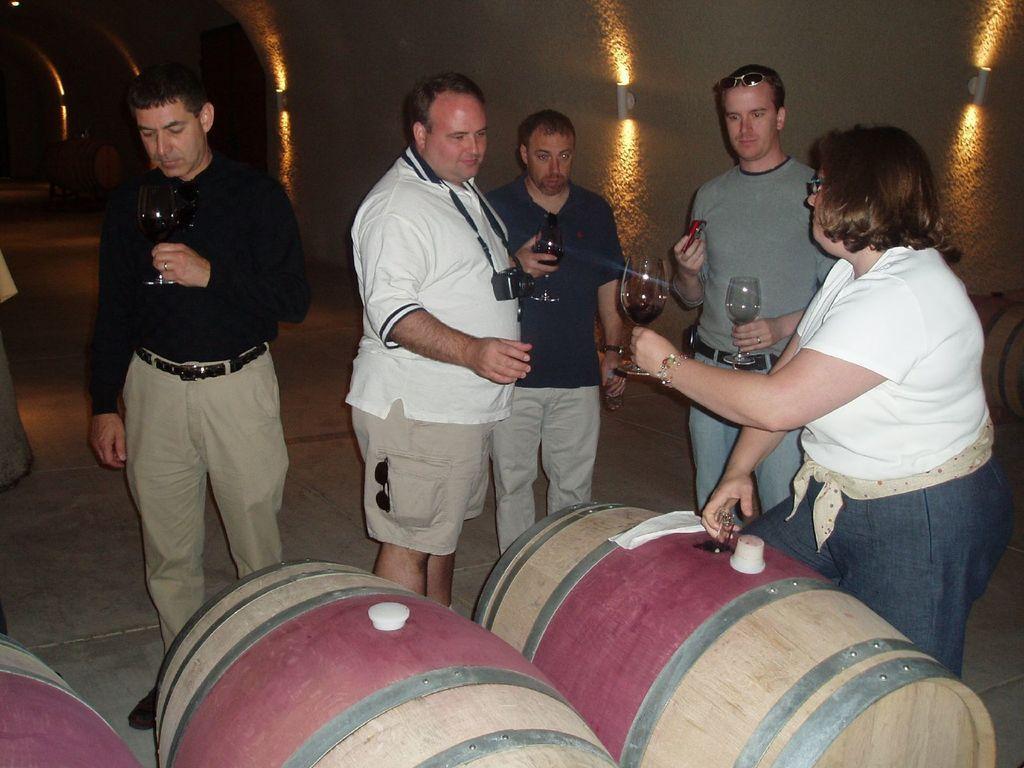How would you summarize this image in a sentence or two? In this image we can see four men and one women are standing and holding glasses in their hand. Woman is wearing white color shirt and the two men are wearing black color dress. One man is wearing white color t-shirt with shorts and one more person is wearing grey t-shirt with jeans. In front of them drums are there. 